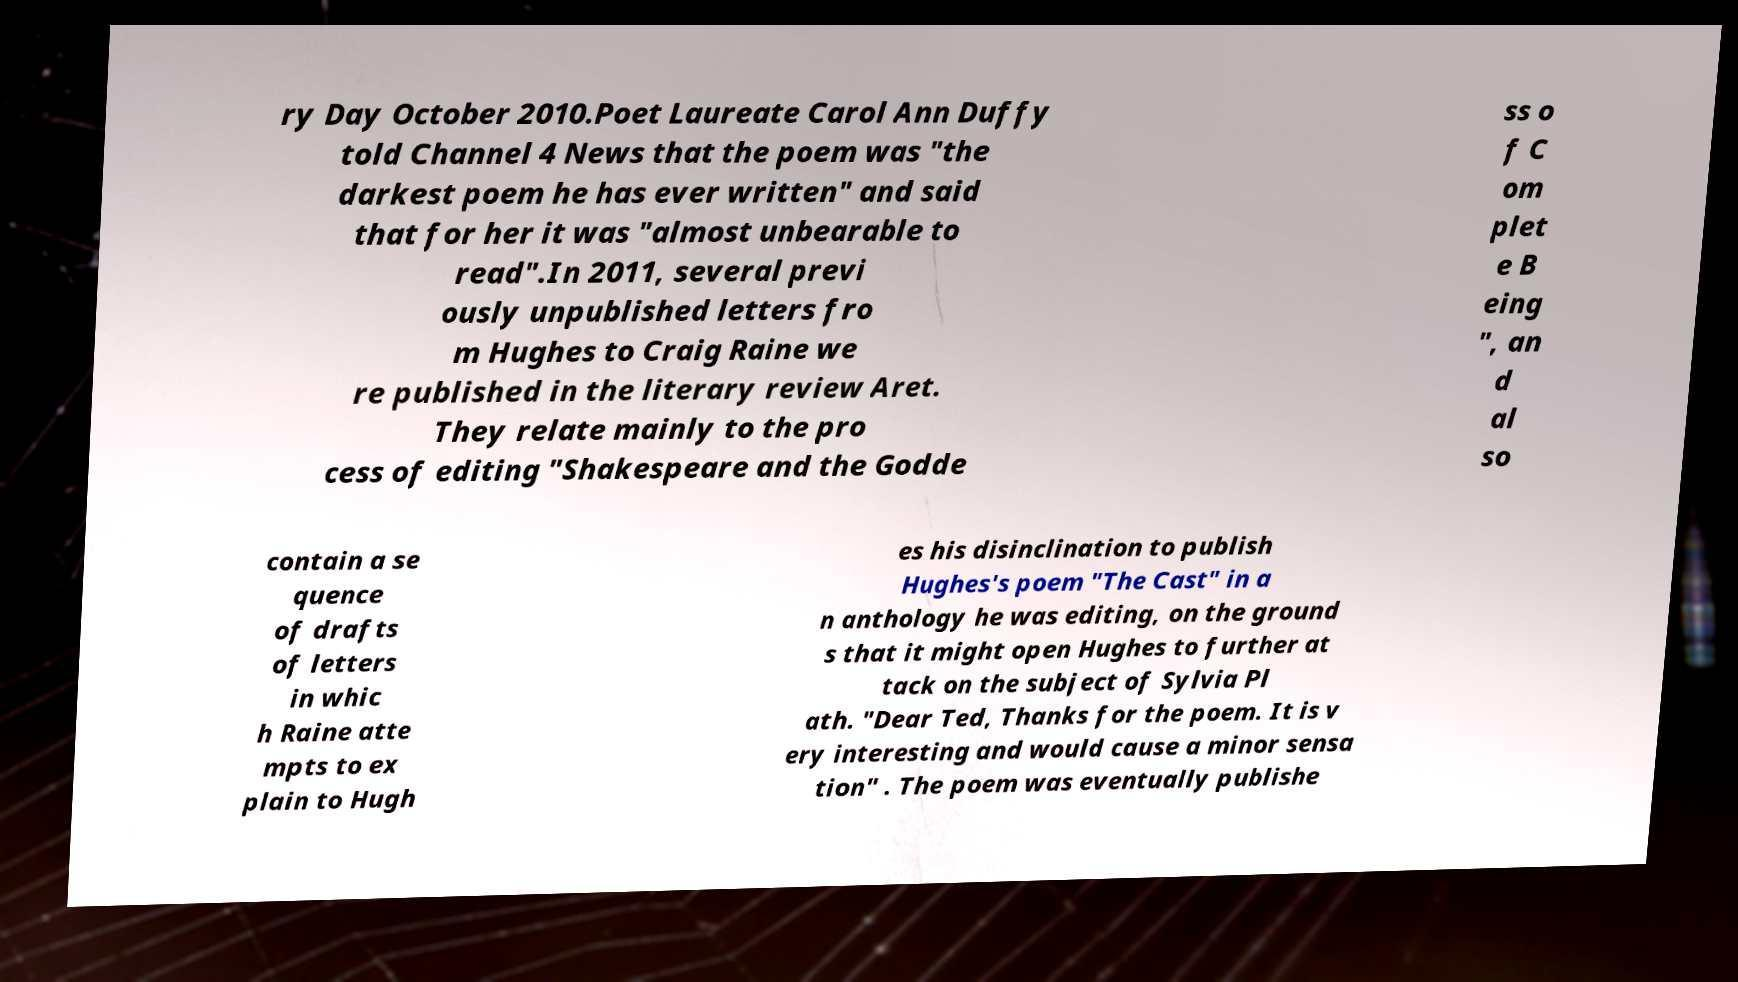What messages or text are displayed in this image? I need them in a readable, typed format. ry Day October 2010.Poet Laureate Carol Ann Duffy told Channel 4 News that the poem was "the darkest poem he has ever written" and said that for her it was "almost unbearable to read".In 2011, several previ ously unpublished letters fro m Hughes to Craig Raine we re published in the literary review Aret. They relate mainly to the pro cess of editing "Shakespeare and the Godde ss o f C om plet e B eing ", an d al so contain a se quence of drafts of letters in whic h Raine atte mpts to ex plain to Hugh es his disinclination to publish Hughes's poem "The Cast" in a n anthology he was editing, on the ground s that it might open Hughes to further at tack on the subject of Sylvia Pl ath. "Dear Ted, Thanks for the poem. It is v ery interesting and would cause a minor sensa tion" . The poem was eventually publishe 